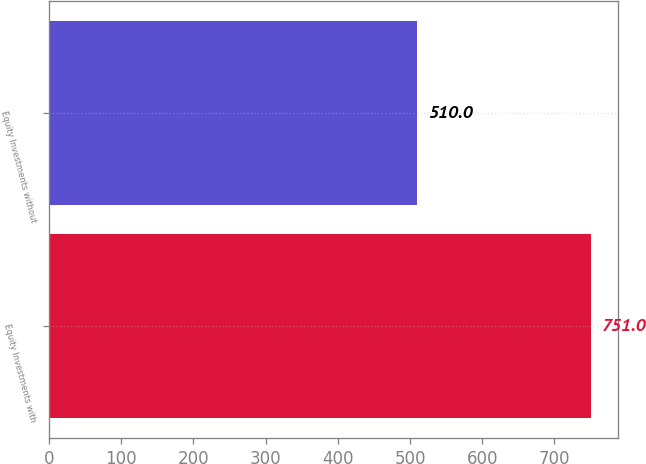Convert chart to OTSL. <chart><loc_0><loc_0><loc_500><loc_500><bar_chart><fcel>Equity Investments with<fcel>Equity Investments without<nl><fcel>751<fcel>510<nl></chart> 